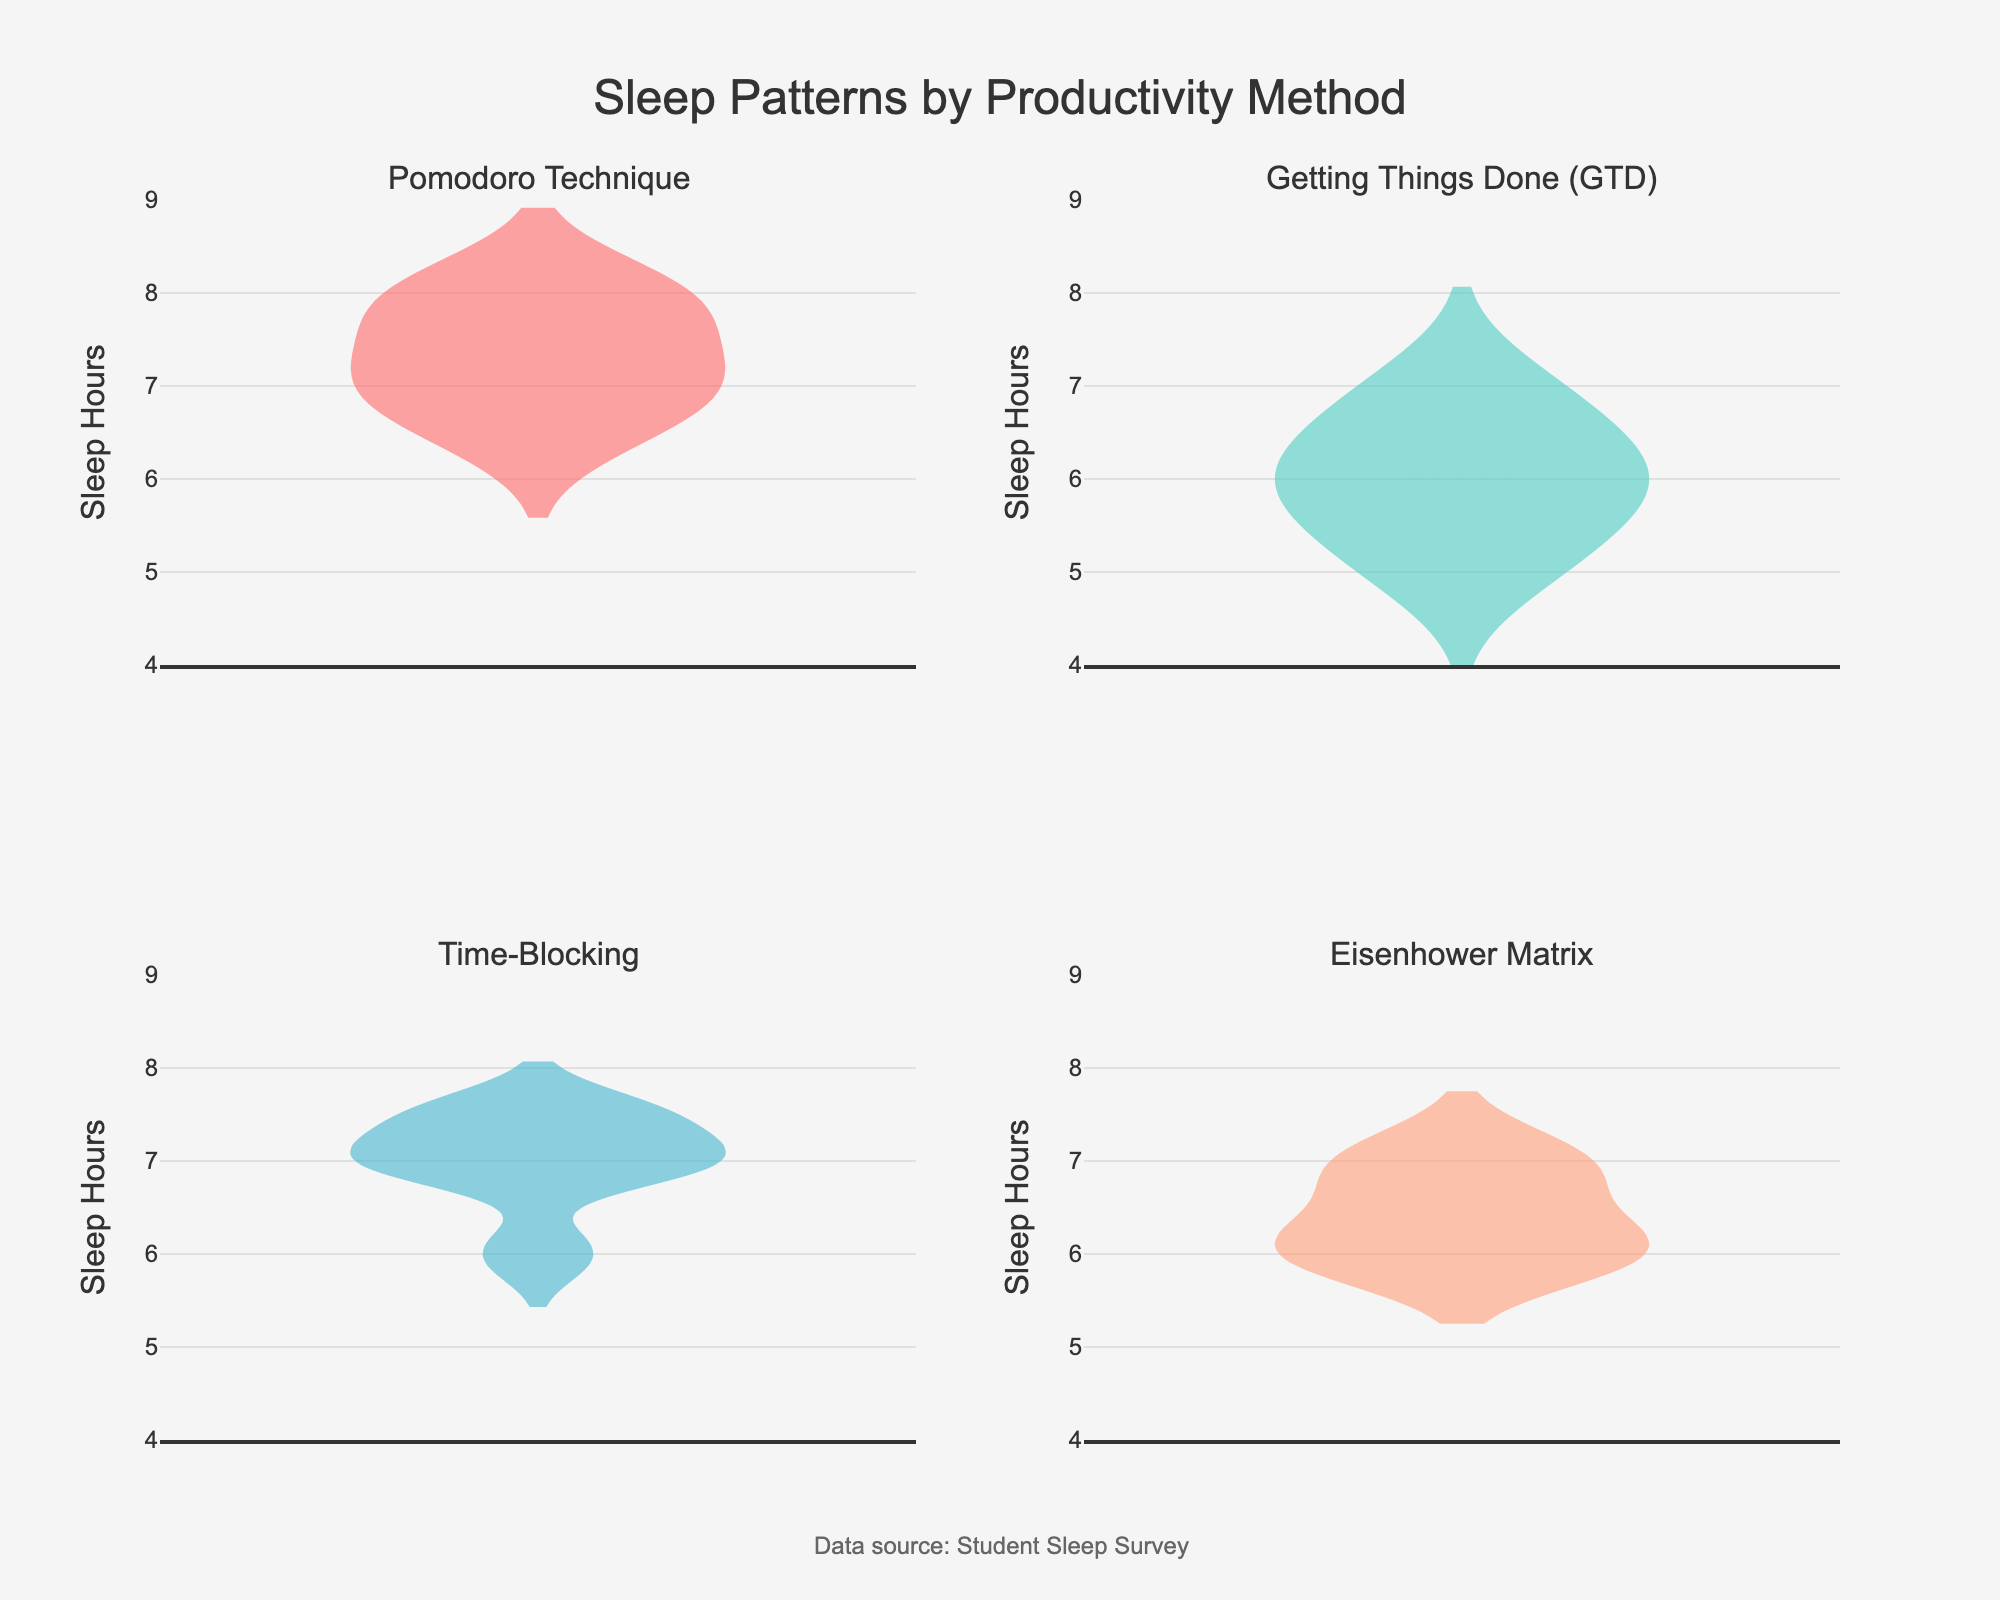What is the title of the figure? The title of the figure is usually located at the top center and provides a brief description of the data being presented. In this case, the title is "Sleep Patterns by Productivity Method".
Answer: Sleep Patterns by Productivity Method What does the y-axis represent? The label on the y-axis typically indicates what variable is being measured. Here, it reads "Sleep Hours", suggesting it represents the number of hours students sleep.
Answer: Sleep Hours Which productivity method shows the highest median sleep hours? To determine the median sleep hours for each productivity method, we can look at the central line inside each violin plot. The Pomodoro Technique violin plot's central line is at 7.0, which is the highest among all methods.
Answer: Pomodoro Technique How does the sleep pattern for "Getting Things Done (GTD)" compare to "Time-Blocking"? By comparing the two violin plots, we can observe that the distribution of sleep hours for GTD is more spread out with a lower median (around 6.0) compared to Time-Blocking, which has a more compact distribution with a higher median at approximately 7.0.
Answer: GTD has a lower median and more spread out distribution compared to Time-Blocking What is the range of sleep hours for the "Eisenhower Matrix" method? The range can be determined by the minimum and maximum points in the violin plot. For Eisenhower Matrix, the range is from around 6.0 to 7.0 hours.
Answer: 6.0 to 7.0 hours Which productivity method has the smallest interquartile range of sleep hours, and what does this indicate? The interquartile range (IQR) is the difference between the first and third quartiles, visible as the width of the central box in each violin plot. The "Pomodoro Technique" shows the smallest IQR, suggesting the sleep hours for students using this method are more consistent.
Answer: Pomodoro Technique Are there any productivity methods where all students have less than 7 hours of sleep? By inspecting the maximum values in each violin plot, the "Getting Things Done (GTD)" method is the only one where all students fall below the 7-hour mark.
Answer: Getting Things Done (GTD) Which productivity method shows the greatest variability in sleep hours? Variability can be assessed by the width and spread of the violin plot. "Getting Things Done (GTD)" shows the widest and most spread out violin plot, indicating the greatest variability.
Answer: Getting Things Done (GTD) How is the data for "Time-Blocking" visually represented in terms of box and mean line? In the violin chart for "Time-Blocking", the central box represents the interquartile range, with a thick central line for the median. The mean line is also visible as a dashed line.
Answer: Box for IQR, thick line for median, dashed line for mean What annotation is included in the figure? Annotations in plots usually provide additional information about the data. Here, there is an annotation at the bottom of the figure reading "Data source: Student Sleep Survey".
Answer: Data source: Student Sleep Survey 